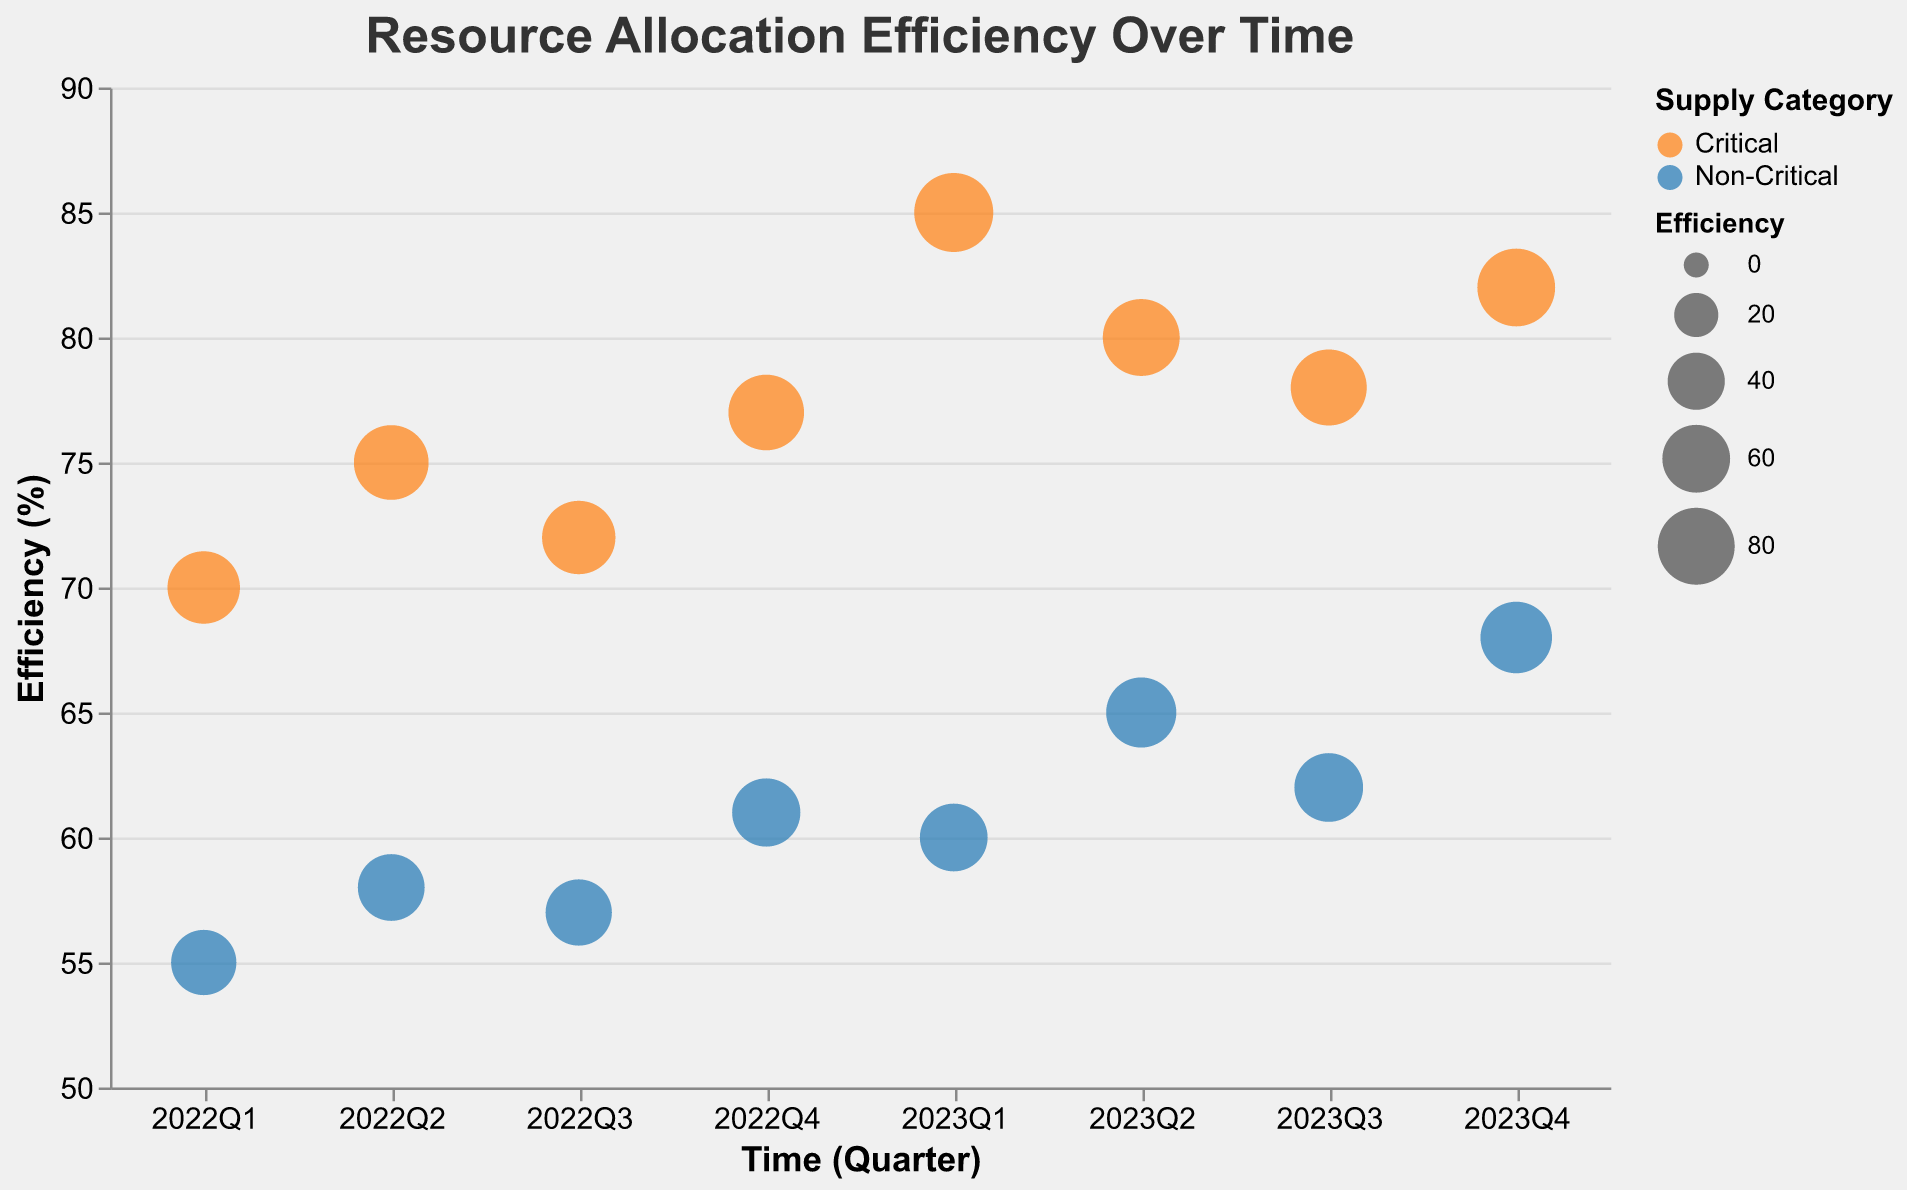What is the overall title of the chart? The title of the chart is displayed at the top of the figure in a larger and bolder font. It serves as a concise summary of the visualized data.
Answer: Resource Allocation Efficiency Over Time What are the highest and lowest efficiency values for critical supplies in 2023? Examine the vertical position of the bubbles within the 'Critical' category for the year 2023 (Q1 to Q4). The highest value is the bubble placed highest in the y-axis and the lowest is the bubble placed lowest.
Answer: Highest: 85%, Lowest: 78% How does the efficiency of non-critical supplies change from 2022 to 2023? Compare the vertical positions of the bubbles for non-critical supplies from 2022 and 2023. The 2022 values (from Q1 to Q4) can be compared to the 2023 values.
Answer: Increases overall from 55%-61% in 2022 to 60%-68% in 2023 Which supply type has the highest efficiency in 2022? Identify bubbles with the highest y-value (efficiency) within the year 2022 and then refer to the tooltip to determine the supply type.
Answer: Medical (Medications) 77% Compare the average efficiency between Critical and Non-Critical supplies over the two-year period. Sum the efficiency values for each category (for both years) and divide by the total number of data points in each category to find the average. Critical: (70+75+72+77+85+80+78+82)/8 = 77.4, Non-Critical: (55+58+57+61+60+65+62+68)/8 = 60.75
Answer: Critical: 77.4%, Non-Critical: 60.75% Which resource showed the most improvement in efficiency from 2022 to 2023 within the Critical category? Track the efficiency values for each named resource from 2022 to 2023 and identify which one increased the most by comparing the difference in their efficiency.
Answer: Medical (First_Aid_Kits) improved from 70% to 85%, an increase of 15% Which quarter in 2023 had the highest efficiency for non-critical supplies? Examine the bubbles corresponding to 'Non-Critical' supplies for each quarter in 2023, and find which is placed highest along the y-axis (efficiency).
Answer: Q4 with 68% Between Medical and Food supplies, which category showed a significant improvement in efficiency over the two-year period for Critical supplies? Compare the efficiency values from 2022 to 2023 for both Medical and Food supplies within Critical supplies. Check which category has the highest increase in efficiency.
Answer: Medical supplies (from 70, 77 in 2022 to 85, 82 in 2023) Which supply type within the Non-Critical category had the least efficiency in 2022? Identify the lowest placed bubbles on the y-axis within the Non-Critical category in 2022 and refer to the tooltip to determine the specific supply type.
Answer: Hygiene (Soap) with 55% What is the difference in efficiency between the highest and the lowest values of Critical supplies in 2023? Extract the highest and lowest efficiency values for Critical supplies in 2023, then subtract the lowest value from the highest value to determine the difference.
Answer: 85% - 78% = 7% 